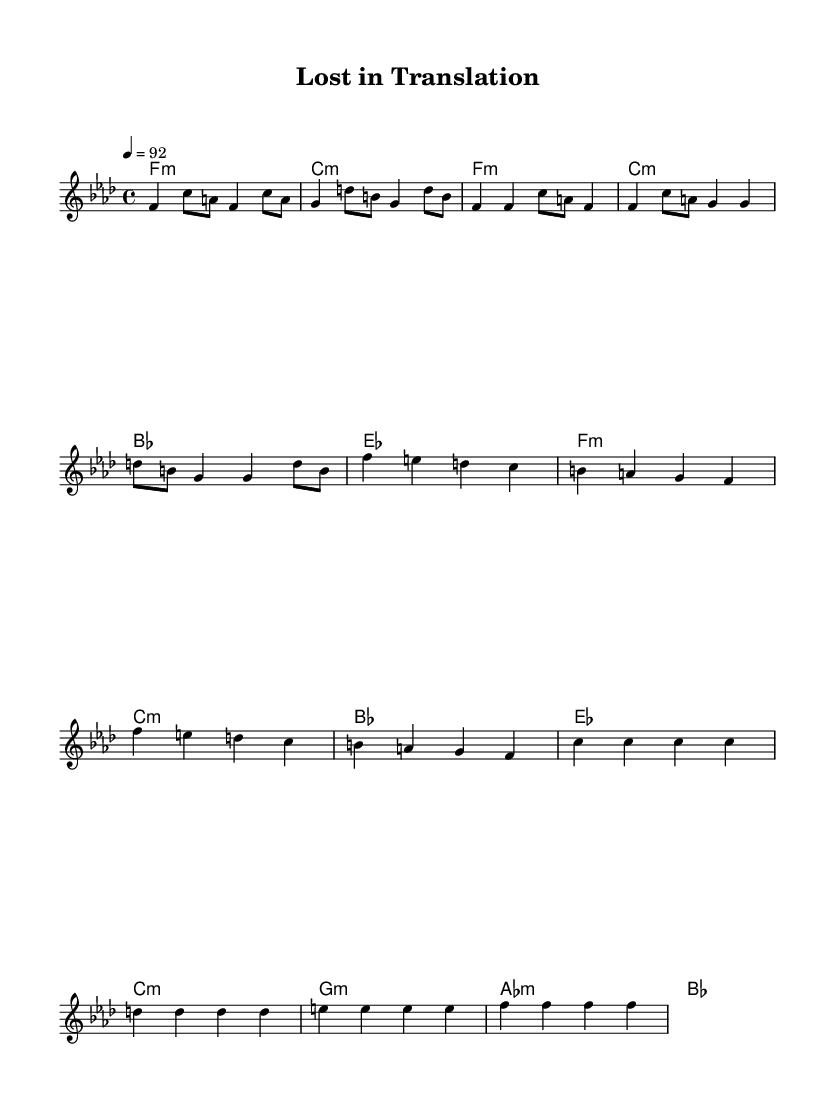What is the key signature of this music? The key signature is F minor, indicated by the presence of four flats.
Answer: F minor What is the time signature of this piece? The time signature is 4/4, meaning there are four beats per measure.
Answer: 4/4 What is the tempo marking of the piece? The tempo marking indicates a speed of 92 beats per minute, as shown at the beginning of the score.
Answer: 92 How many measures are in the chorus section? The chorus section consists of 4 measures, easily counted in the score under the section labeled "Chorus."
Answer: 4 What type of harmony is predominantly used throughout the piece? The harmony is primarily based on minor chords, as seen in the chord progression throughout the music.
Answer: Minor What is the name of the title? The title "Lost in Translation" is indicated at the top of the sheet music.
Answer: Lost in Translation How does the bridge section differ in chord progression compared to the verse? The bridge introduces different chords such as C minor and G minor, contrasting with the verse's F minor and C minor.
Answer: Different chords 